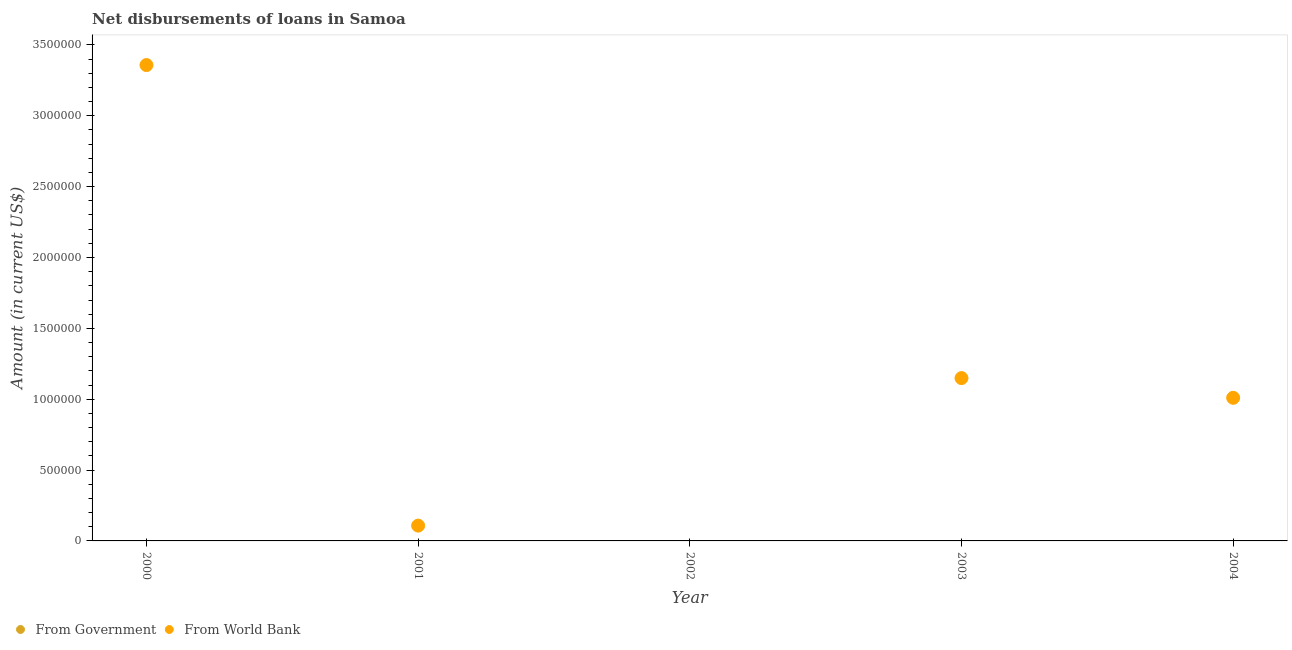Is the number of dotlines equal to the number of legend labels?
Give a very brief answer. No. Across all years, what is the maximum net disbursements of loan from world bank?
Your response must be concise. 3.36e+06. In which year was the net disbursements of loan from world bank maximum?
Offer a very short reply. 2000. What is the total net disbursements of loan from world bank in the graph?
Ensure brevity in your answer.  5.62e+06. What is the difference between the net disbursements of loan from world bank in 2001 and that in 2003?
Make the answer very short. -1.04e+06. What is the average net disbursements of loan from world bank per year?
Give a very brief answer. 1.12e+06. What is the ratio of the net disbursements of loan from world bank in 2000 to that in 2004?
Your answer should be very brief. 3.32. What is the difference between the highest and the second highest net disbursements of loan from world bank?
Ensure brevity in your answer.  2.21e+06. What is the difference between the highest and the lowest net disbursements of loan from world bank?
Your answer should be compact. 3.36e+06. In how many years, is the net disbursements of loan from world bank greater than the average net disbursements of loan from world bank taken over all years?
Provide a succinct answer. 2. Is the net disbursements of loan from government strictly less than the net disbursements of loan from world bank over the years?
Ensure brevity in your answer.  No. How many years are there in the graph?
Give a very brief answer. 5. What is the difference between two consecutive major ticks on the Y-axis?
Offer a terse response. 5.00e+05. Does the graph contain grids?
Your response must be concise. No. How many legend labels are there?
Make the answer very short. 2. What is the title of the graph?
Offer a terse response. Net disbursements of loans in Samoa. What is the label or title of the Y-axis?
Give a very brief answer. Amount (in current US$). What is the Amount (in current US$) of From Government in 2000?
Provide a short and direct response. 0. What is the Amount (in current US$) of From World Bank in 2000?
Give a very brief answer. 3.36e+06. What is the Amount (in current US$) of From Government in 2001?
Keep it short and to the point. 0. What is the Amount (in current US$) of From World Bank in 2001?
Offer a very short reply. 1.08e+05. What is the Amount (in current US$) of From Government in 2003?
Provide a succinct answer. 0. What is the Amount (in current US$) in From World Bank in 2003?
Your answer should be compact. 1.15e+06. What is the Amount (in current US$) in From World Bank in 2004?
Offer a terse response. 1.01e+06. Across all years, what is the maximum Amount (in current US$) in From World Bank?
Keep it short and to the point. 3.36e+06. Across all years, what is the minimum Amount (in current US$) of From World Bank?
Your response must be concise. 0. What is the total Amount (in current US$) of From Government in the graph?
Make the answer very short. 0. What is the total Amount (in current US$) in From World Bank in the graph?
Provide a short and direct response. 5.62e+06. What is the difference between the Amount (in current US$) of From World Bank in 2000 and that in 2001?
Your answer should be compact. 3.25e+06. What is the difference between the Amount (in current US$) in From World Bank in 2000 and that in 2003?
Give a very brief answer. 2.21e+06. What is the difference between the Amount (in current US$) of From World Bank in 2000 and that in 2004?
Keep it short and to the point. 2.35e+06. What is the difference between the Amount (in current US$) in From World Bank in 2001 and that in 2003?
Keep it short and to the point. -1.04e+06. What is the difference between the Amount (in current US$) of From World Bank in 2001 and that in 2004?
Keep it short and to the point. -9.02e+05. What is the difference between the Amount (in current US$) of From World Bank in 2003 and that in 2004?
Ensure brevity in your answer.  1.39e+05. What is the average Amount (in current US$) of From Government per year?
Provide a short and direct response. 0. What is the average Amount (in current US$) of From World Bank per year?
Keep it short and to the point. 1.12e+06. What is the ratio of the Amount (in current US$) in From World Bank in 2000 to that in 2001?
Provide a succinct answer. 31.09. What is the ratio of the Amount (in current US$) of From World Bank in 2000 to that in 2003?
Provide a short and direct response. 2.92. What is the ratio of the Amount (in current US$) in From World Bank in 2000 to that in 2004?
Provide a short and direct response. 3.32. What is the ratio of the Amount (in current US$) of From World Bank in 2001 to that in 2003?
Your answer should be compact. 0.09. What is the ratio of the Amount (in current US$) of From World Bank in 2001 to that in 2004?
Your answer should be very brief. 0.11. What is the ratio of the Amount (in current US$) of From World Bank in 2003 to that in 2004?
Offer a very short reply. 1.14. What is the difference between the highest and the second highest Amount (in current US$) of From World Bank?
Give a very brief answer. 2.21e+06. What is the difference between the highest and the lowest Amount (in current US$) in From World Bank?
Your response must be concise. 3.36e+06. 